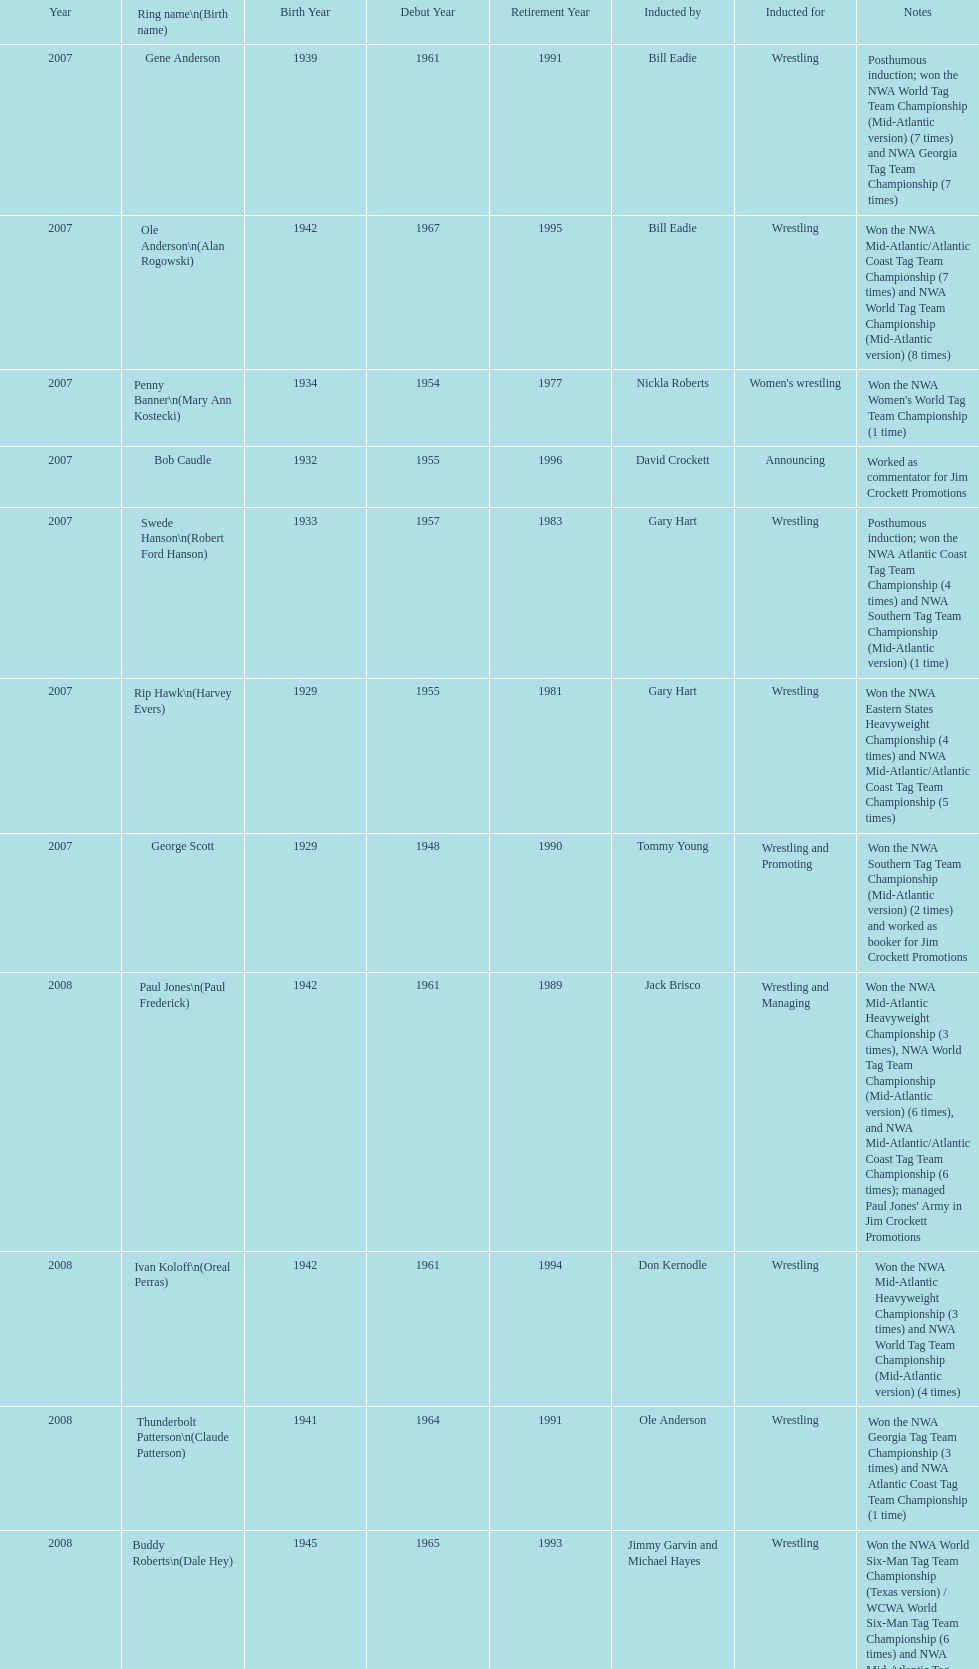How many members were inducted for announcing? 2. 